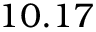<formula> <loc_0><loc_0><loc_500><loc_500>1 0 . 1 7</formula> 